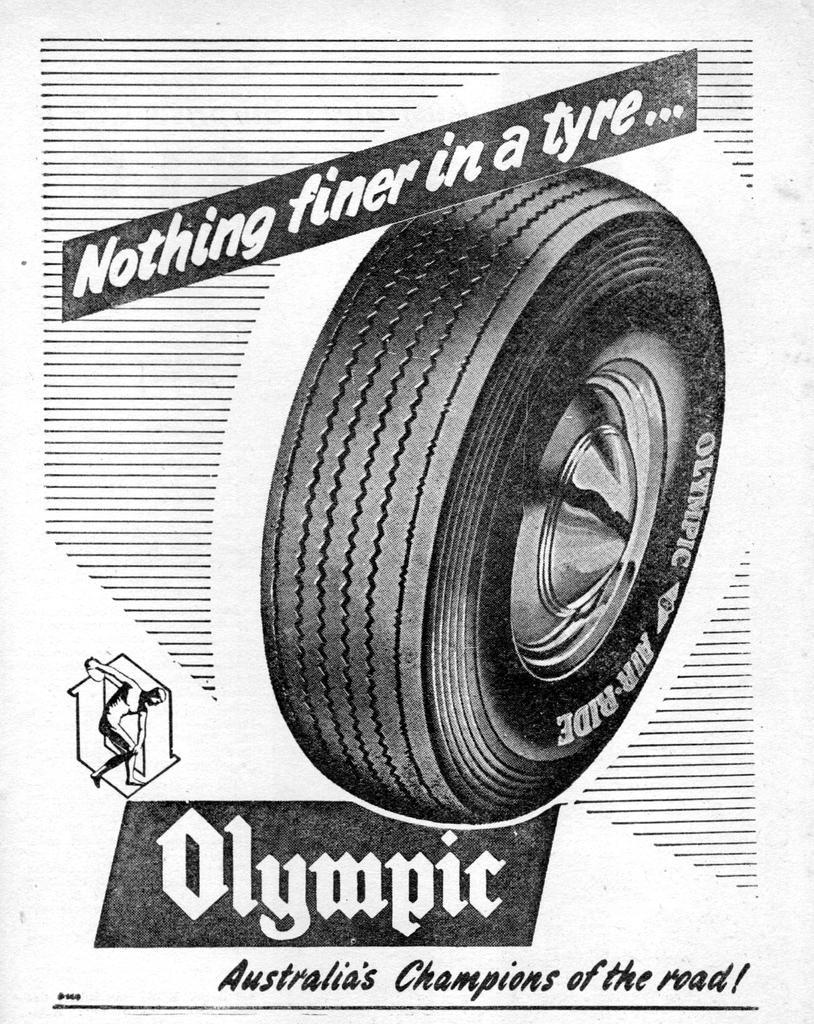How would you summarize this image in a sentence or two? in this image there is a poster about the tire. In the middle there is a tire. There is text on either side of the tire. 